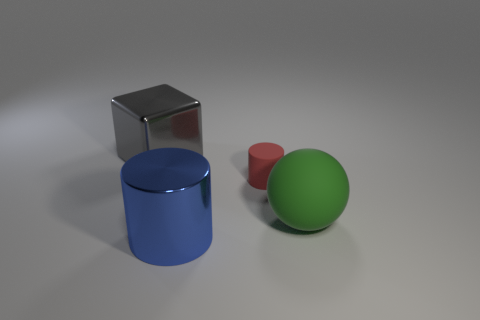Can you describe the lighting and shadows in the scene? The lighting in the scene is soft and diffuse, coming from a direction that is off-camera, possibly overhead given the nature of the shadows. Each object casts a soft-edged shadow directly opposite the light source, contributing to a sense of depth and dimensionality in the composition. 